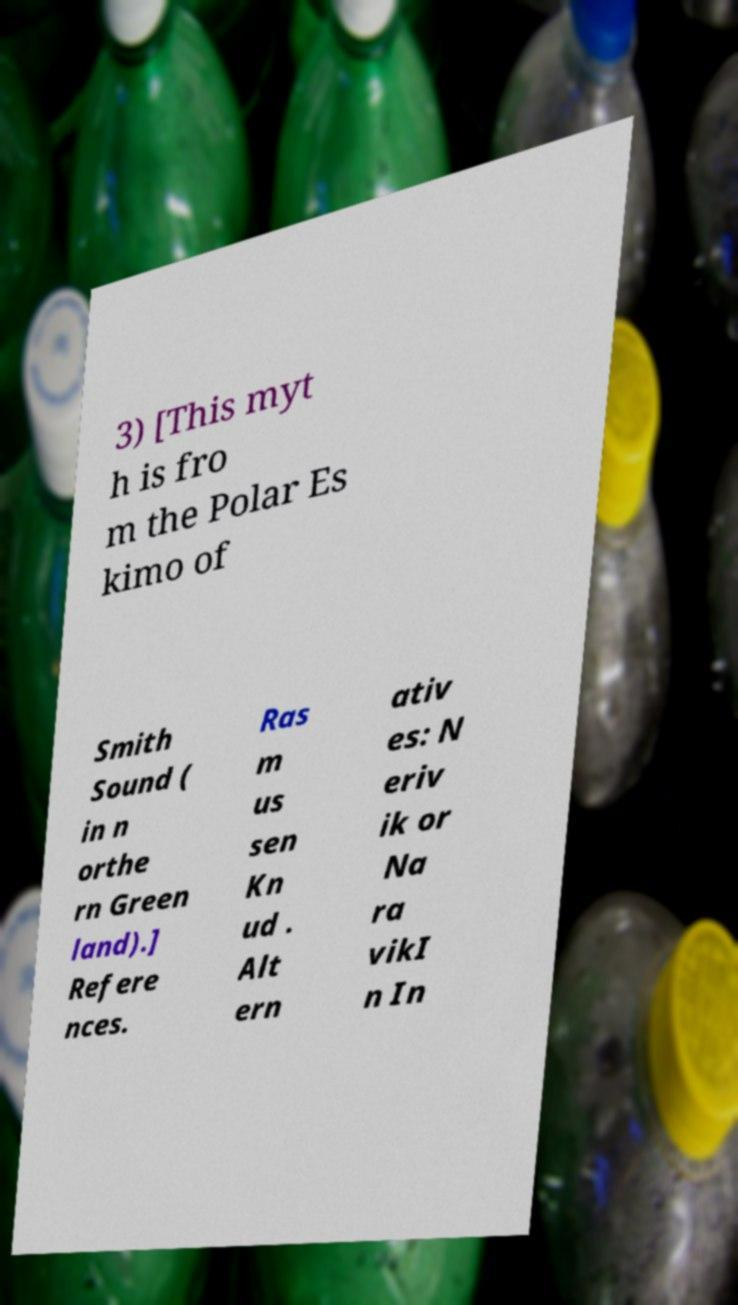What messages or text are displayed in this image? I need them in a readable, typed format. 3) [This myt h is fro m the Polar Es kimo of Smith Sound ( in n orthe rn Green land).] Refere nces. Ras m us sen Kn ud . Alt ern ativ es: N eriv ik or Na ra vikI n In 